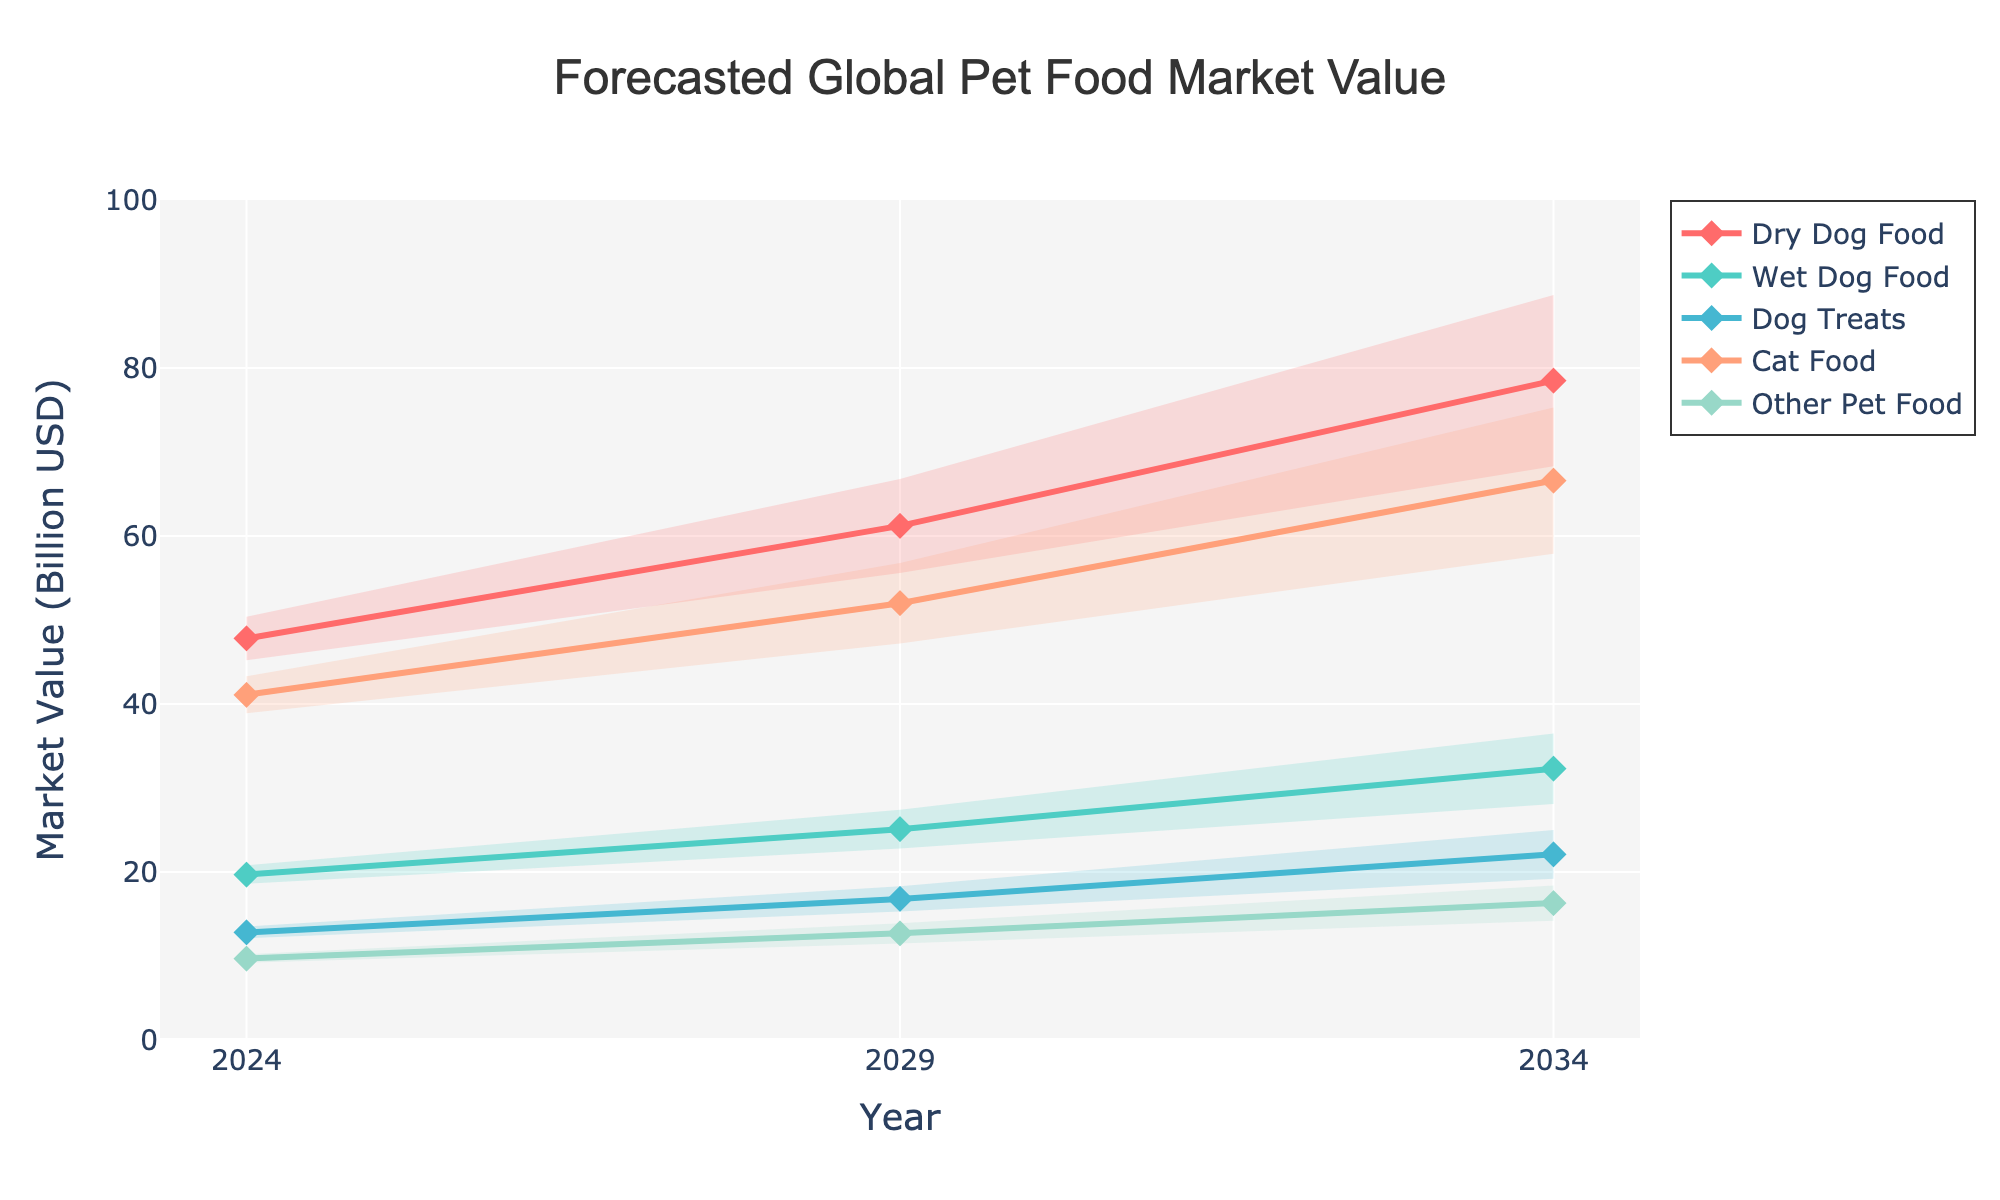What is the title of the chart? The title is displayed at the top center of the chart and is the largest text. It states the main subject of the figure.
Answer: Forecasted Global Pet Food Market Value How many product categories are shown in the forecast? The chart uses different colors for each category and the legend specifies them. Count the number of categories listed.
Answer: 5 What is the mid estimate for Dry Dog Food in 2024? Locate the line that represents Dry Dog Food for the year 2024 and refer to the mid estimate value on the y-axis.
Answer: 47.8 billion USD Which product category has the highest mid estimate in 2034? Compare the mid estimates for all categories in 2034 and identify the one with the highest value.
Answer: Cat Food By how much is the mid estimate of Dog Treats expected to increase from 2024 to 2034? Find the mid estimates of Dog Treats for both years and calculate the difference.
Answer: 22.1 - 12.8 = 9.3 billion USD What is the range of the estimate for Wet Dog Food in 2029? Look at the high and low estimates for Wet Dog Food in 2029 and subtract the low from the high.
Answer: 27.4 - 22.8 = 4.6 billion USD Which year shows the highest high estimate for Other Pet Food? Compare the high estimates for Other Pet Food across all years and identify the maximum value and corresponding year.
Answer: 2034 In which year does Cat Food have the smallest range between low and high estimates? Calculate the range for each year as (high estimate - low estimate) and compare, identifying the smallest one.
Answer: 2024 How do the mid estimates for Wet Dog Food compare to Dog Treats in 2034? Look at the mid estimates for both Wet Dog Food and Dog Treats in the year 2034 and compare them directly.
Answer: Wet Dog Food has a higher mid estimate (32.3 billion USD vs 22.1 billion USD) What is the trend for the mid estimate of Dry Dog Food from 2024 to 2034? Observe the mid estimates for Dry Dog Food over the years and describe the pattern.
Answer: Increasing trend 